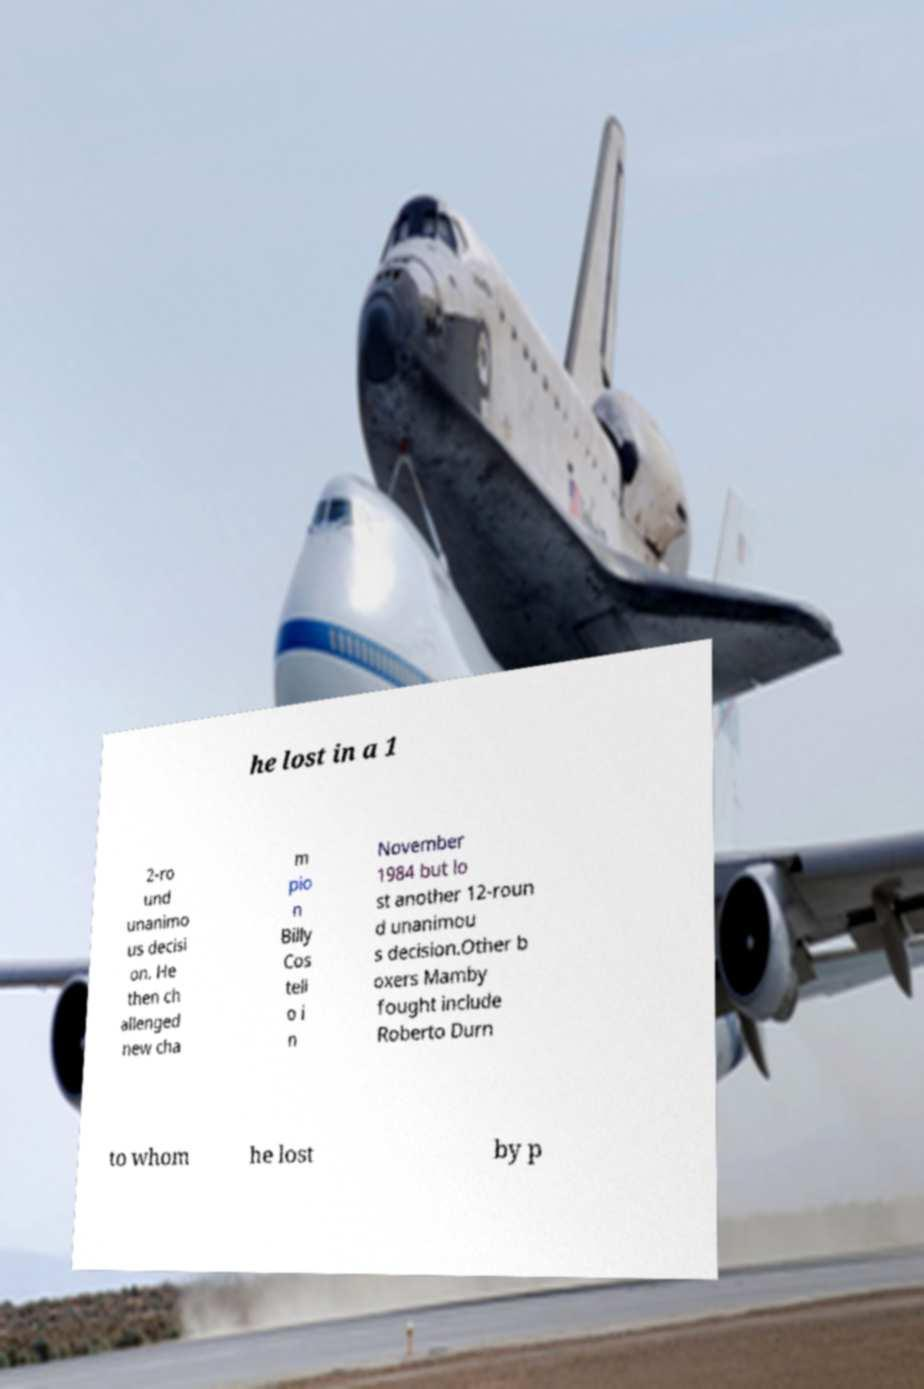I need the written content from this picture converted into text. Can you do that? he lost in a 1 2-ro und unanimo us decisi on. He then ch allenged new cha m pio n Billy Cos tell o i n November 1984 but lo st another 12-roun d unanimou s decision.Other b oxers Mamby fought include Roberto Durn to whom he lost by p 